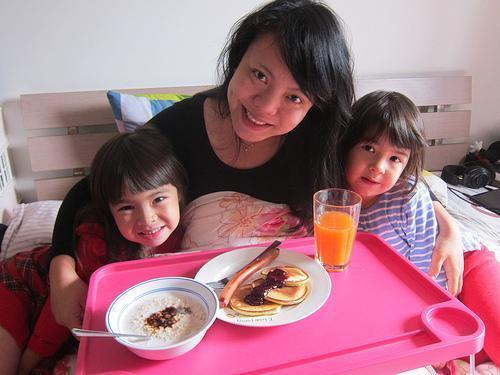How many people are in this picture?
Give a very brief answer. 3. 